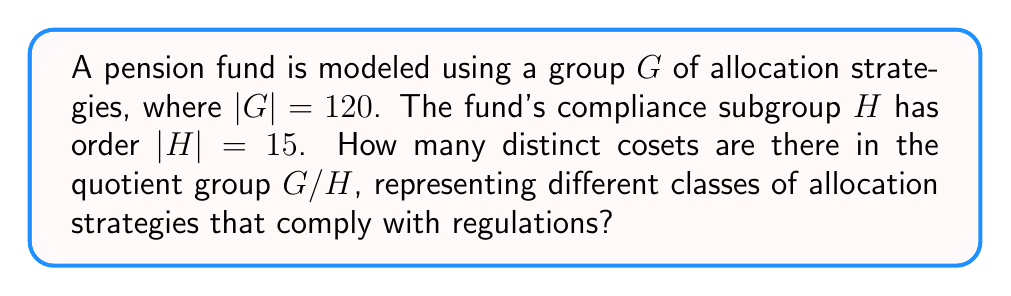Can you solve this math problem? To solve this problem, we'll follow these steps:

1) Recall the definition of a quotient group: For a group $G$ and a normal subgroup $H$, the quotient group $G/H$ is the set of all cosets of $H$ in $G$.

2) The number of cosets in $G/H$ is equal to the index of $H$ in $G$, denoted as $[G:H]$.

3) The index $[G:H]$ is given by the formula:

   $$[G:H] = \frac{|G|}{|H|}$$

   Where $|G|$ is the order of group $G$, and $|H|$ is the order of subgroup $H$.

4) We are given:
   $|G| = 120$
   $|H| = 15$

5) Substituting these values into the formula:

   $$[G:H] = \frac{120}{15}$$

6) Simplify:
   $$[G:H] = 8$$

Therefore, there are 8 distinct cosets in the quotient group $G/H$, representing 8 different classes of allocation strategies that comply with regulations.
Answer: 8 